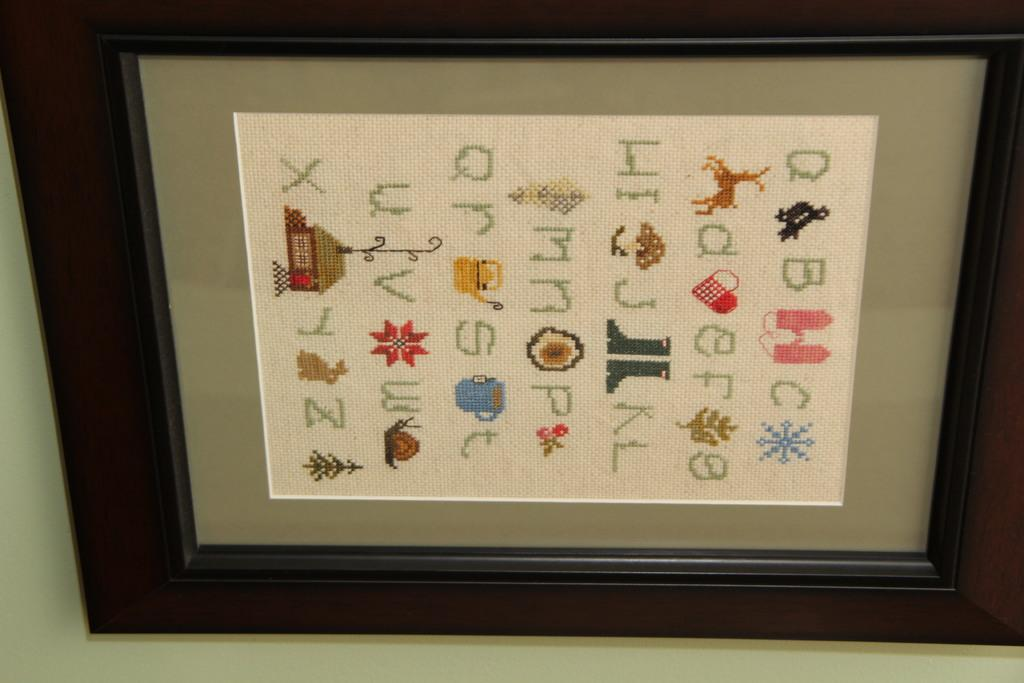Provide a one-sentence caption for the provided image. A framed needlepoint piece with upper and lower case letters of the alphabet, A to Z. 